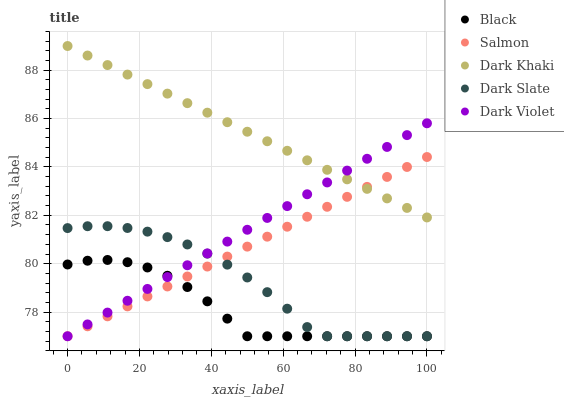Does Black have the minimum area under the curve?
Answer yes or no. Yes. Does Dark Khaki have the maximum area under the curve?
Answer yes or no. Yes. Does Salmon have the minimum area under the curve?
Answer yes or no. No. Does Salmon have the maximum area under the curve?
Answer yes or no. No. Is Salmon the smoothest?
Answer yes or no. Yes. Is Black the roughest?
Answer yes or no. Yes. Is Black the smoothest?
Answer yes or no. No. Is Salmon the roughest?
Answer yes or no. No. Does Salmon have the lowest value?
Answer yes or no. Yes. Does Dark Khaki have the highest value?
Answer yes or no. Yes. Does Salmon have the highest value?
Answer yes or no. No. Is Black less than Dark Khaki?
Answer yes or no. Yes. Is Dark Khaki greater than Dark Slate?
Answer yes or no. Yes. Does Dark Slate intersect Dark Violet?
Answer yes or no. Yes. Is Dark Slate less than Dark Violet?
Answer yes or no. No. Is Dark Slate greater than Dark Violet?
Answer yes or no. No. Does Black intersect Dark Khaki?
Answer yes or no. No. 